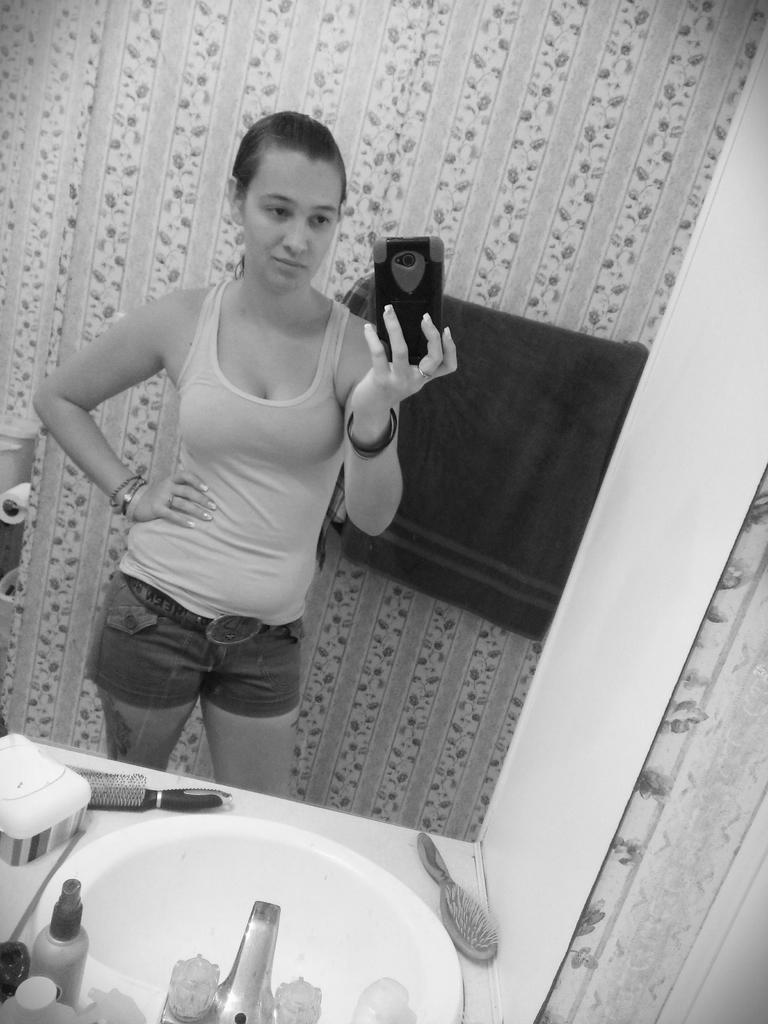In one or two sentences, can you explain what this image depicts? In the image we can see black and white picture of a woman wearing clothes, bracelets and she is holding a mobile phone in her hand. Here we can see basin, water tap, combs and bottles. Here we can see tissue roll and the wall.  